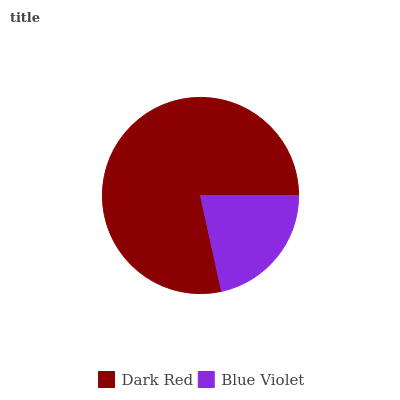Is Blue Violet the minimum?
Answer yes or no. Yes. Is Dark Red the maximum?
Answer yes or no. Yes. Is Blue Violet the maximum?
Answer yes or no. No. Is Dark Red greater than Blue Violet?
Answer yes or no. Yes. Is Blue Violet less than Dark Red?
Answer yes or no. Yes. Is Blue Violet greater than Dark Red?
Answer yes or no. No. Is Dark Red less than Blue Violet?
Answer yes or no. No. Is Dark Red the high median?
Answer yes or no. Yes. Is Blue Violet the low median?
Answer yes or no. Yes. Is Blue Violet the high median?
Answer yes or no. No. Is Dark Red the low median?
Answer yes or no. No. 